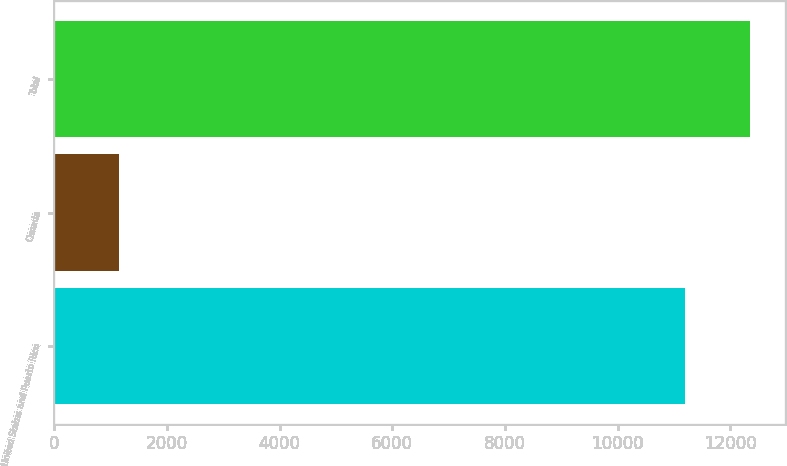<chart> <loc_0><loc_0><loc_500><loc_500><bar_chart><fcel>United States and Puerto Rico<fcel>Canada<fcel>Total<nl><fcel>11198<fcel>1146<fcel>12344<nl></chart> 